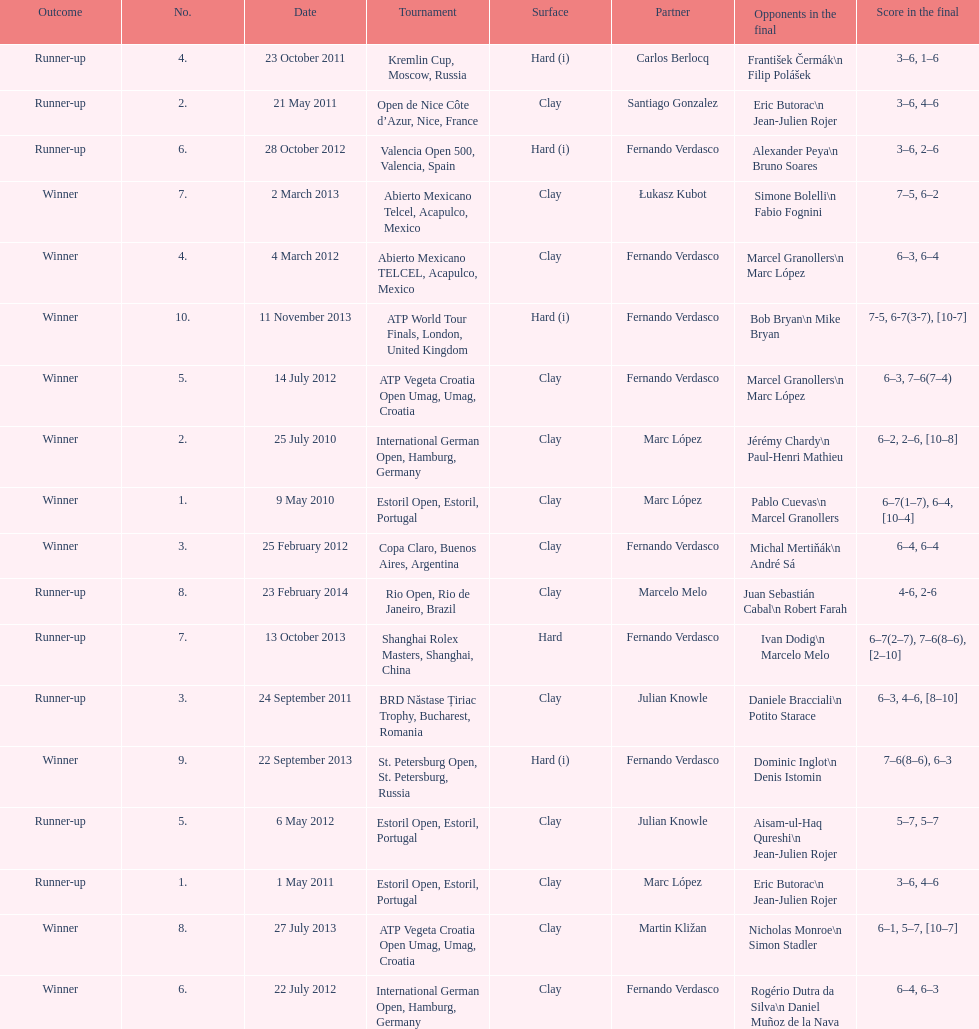Who was this player's next partner after playing with marc lopez in may 2011? Santiago Gonzalez. 